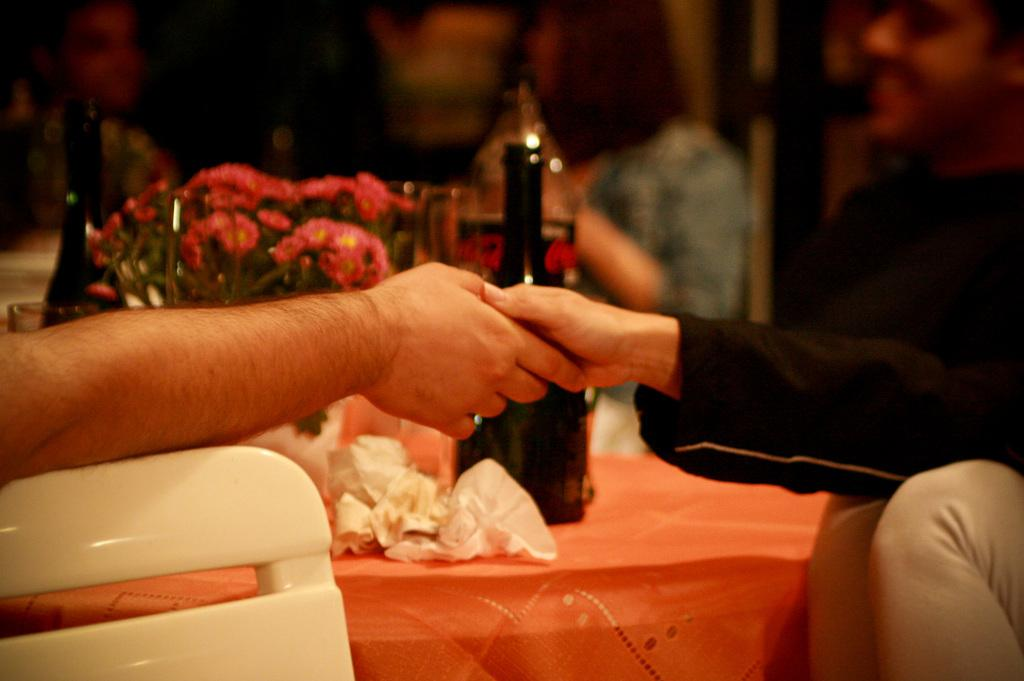How many people are in the image? There are two persons in the image. What are the two persons doing? The two persons are holding hands. What can be seen in the background of the image? There are bottles in the background of the image. What type of flowers are present in the image? There are pink flowers in the image. Can you tell me how many times the giraffe jumps in the image? There is no giraffe present in the image, so it cannot be determined how many times it jumps. What type of loaf is being used as a prop in the image? There is no loaf present in the image, so it cannot be determined what type of loaf might be used as a prop. 